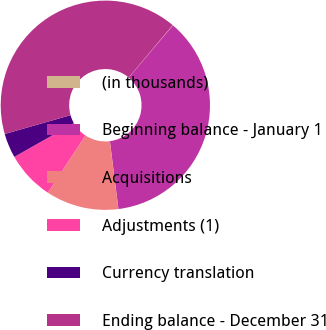<chart> <loc_0><loc_0><loc_500><loc_500><pie_chart><fcel>(in thousands)<fcel>Beginning balance - January 1<fcel>Acquisitions<fcel>Adjustments (1)<fcel>Currency translation<fcel>Ending balance - December 31<nl><fcel>0.06%<fcel>36.82%<fcel>11.26%<fcel>7.52%<fcel>3.79%<fcel>40.55%<nl></chart> 